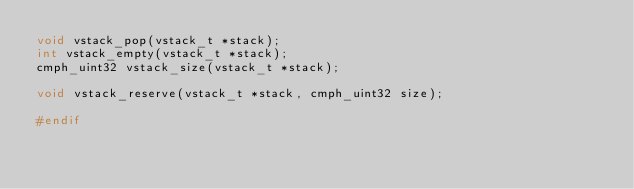Convert code to text. <code><loc_0><loc_0><loc_500><loc_500><_C_>void vstack_pop(vstack_t *stack);
int vstack_empty(vstack_t *stack);
cmph_uint32 vstack_size(vstack_t *stack);

void vstack_reserve(vstack_t *stack, cmph_uint32 size);

#endif
</code> 